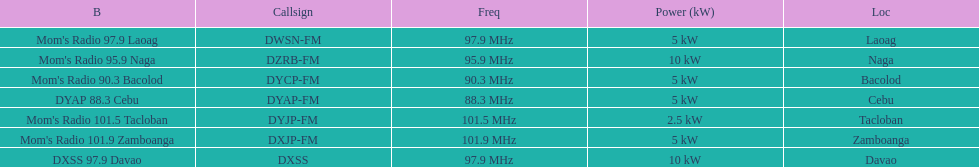What is the radio with the least about of mhz? DYAP 88.3 Cebu. 